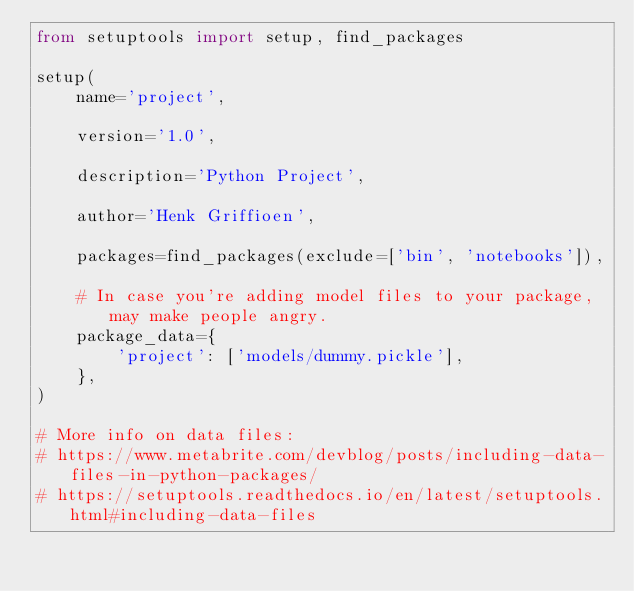Convert code to text. <code><loc_0><loc_0><loc_500><loc_500><_Python_>from setuptools import setup, find_packages

setup(
    name='project',

    version='1.0',

    description='Python Project',

    author='Henk Griffioen',

    packages=find_packages(exclude=['bin', 'notebooks']),

    # In case you're adding model files to your package, may make people angry.
    package_data={
        'project': ['models/dummy.pickle'],
    },
)

# More info on data files:
# https://www.metabrite.com/devblog/posts/including-data-files-in-python-packages/
# https://setuptools.readthedocs.io/en/latest/setuptools.html#including-data-files
</code> 